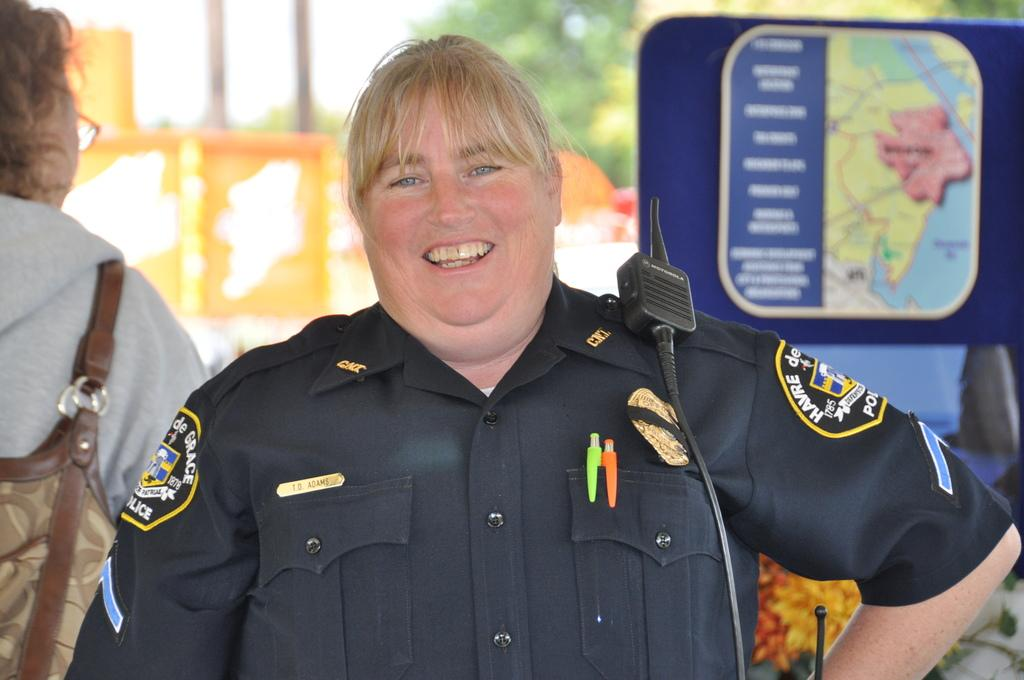What is the main subject of the image? There is a person standing and smiling in the center of the image. Can you describe the person in the background? The person in the background is wearing a bag. What can be seen in the background of the image? There is a board visible in the background of the image. What type of cave can be seen in the background of the image? There is no cave present in the image; it features a person standing and smiling in the center and a person in the background with a board visible. 